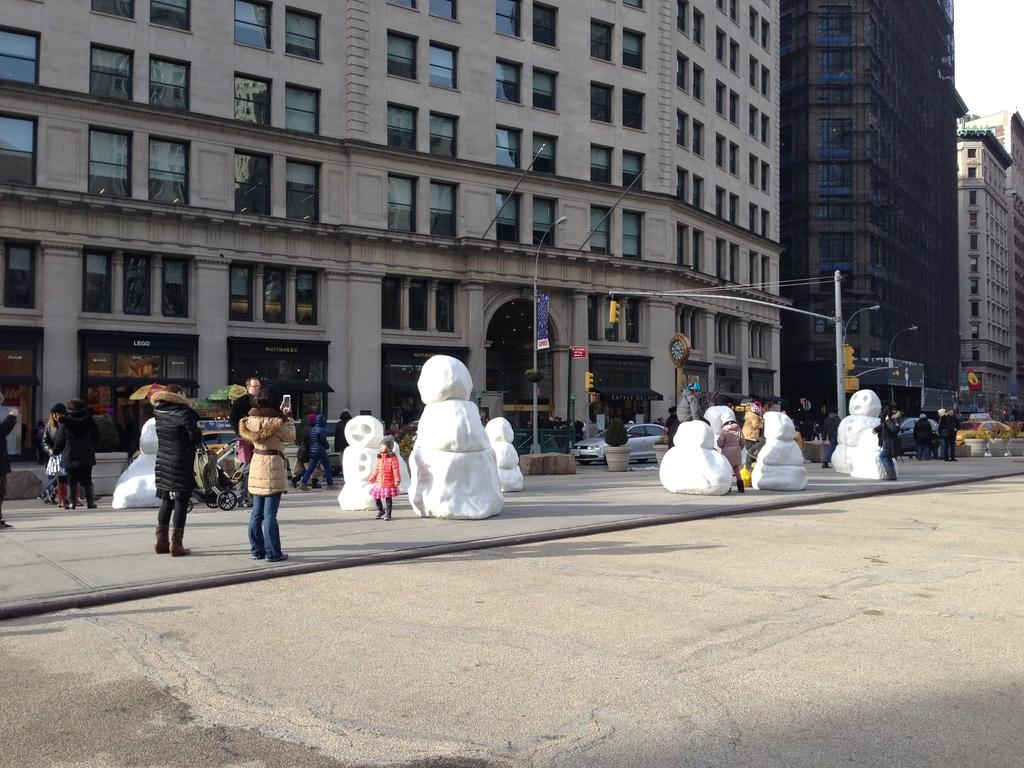What type of sculptures can be seen in the image? There are snow sculptures in the image. Are there any people present near the sculptures? Yes, there are people around the snow sculptures. What can be seen in the background behind the people? Tall buildings are visible behind the people. What type of wood is being used to plough the snow in the image? There is no plough or wood present in the image; it features snow sculptures and people. How many chickens can be seen interacting with the snow sculptures in the image? There are no chickens present in the image. 